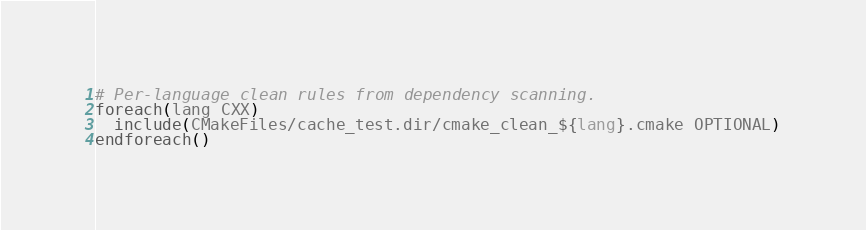<code> <loc_0><loc_0><loc_500><loc_500><_CMake_>
# Per-language clean rules from dependency scanning.
foreach(lang CXX)
  include(CMakeFiles/cache_test.dir/cmake_clean_${lang}.cmake OPTIONAL)
endforeach()
</code> 